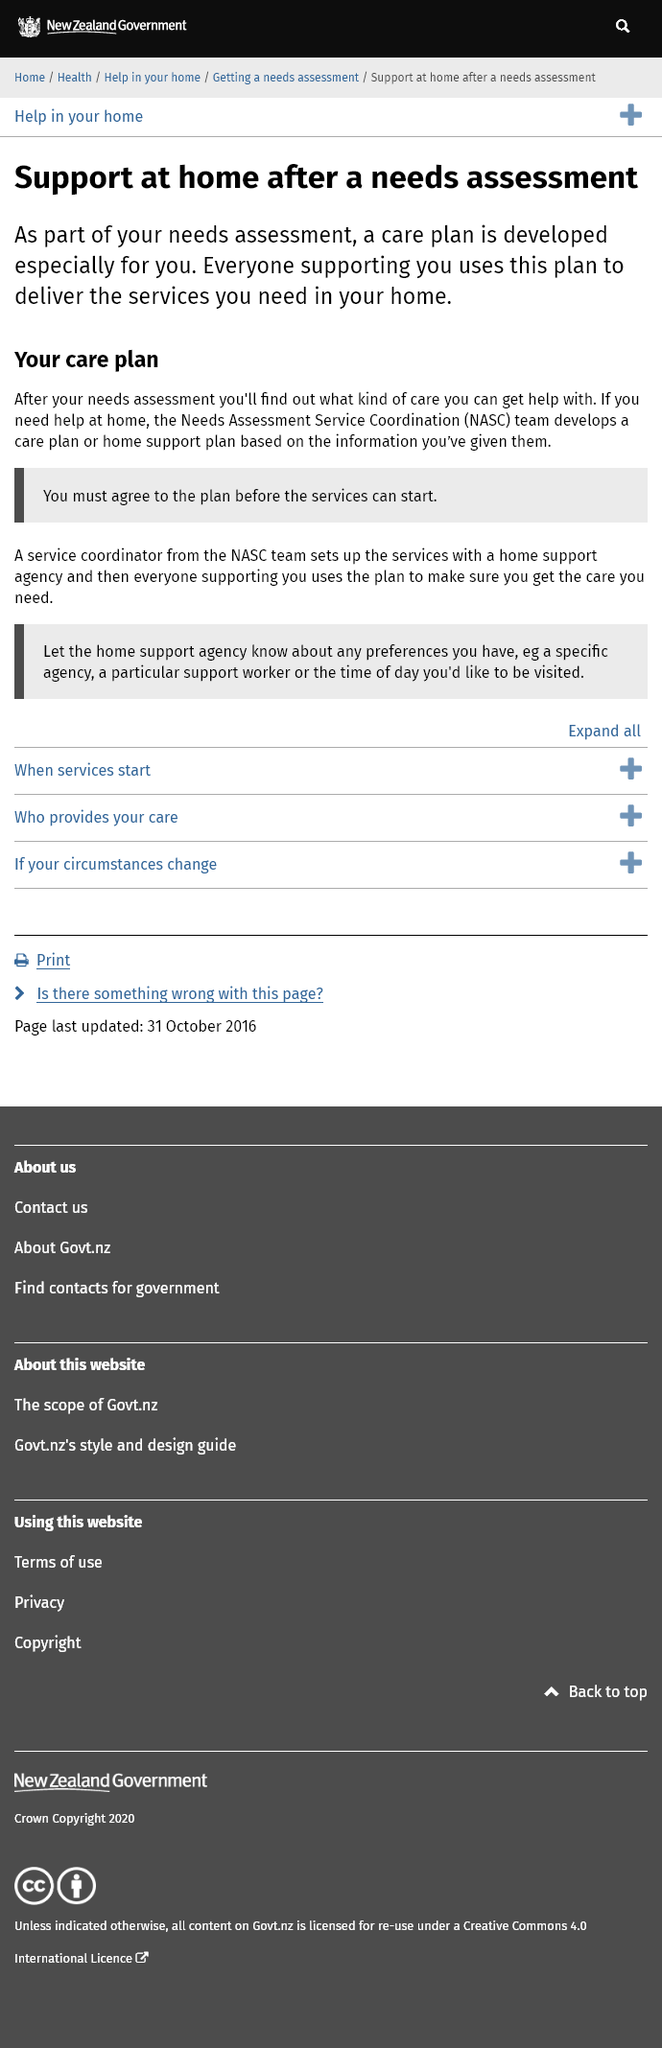Indicate a few pertinent items in this graphic. It is necessary to agree to the support at home plan developed by the NASC team prior to the commencement of services. The Needs Assessment Service Coordination team will develop a care or home support plan for me if I need help at home and require assistance in developing a plan. The service coordinator from the NASC team will set up the services for the client with a home support agency. 